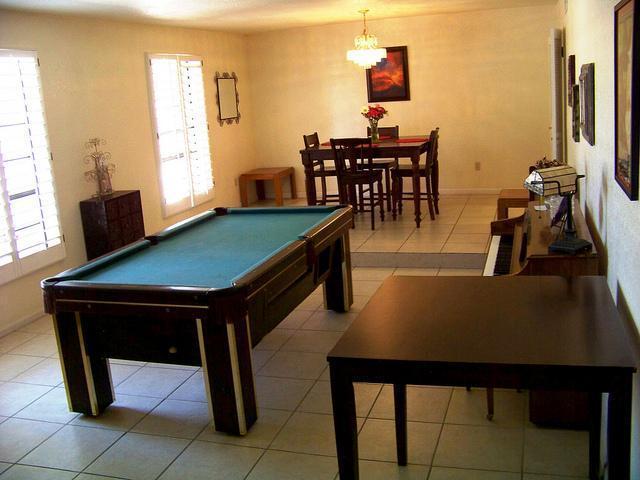How many lights are hanging from the ceiling?
Give a very brief answer. 1. How many people can sit at the same table?
Give a very brief answer. 4. How many lights are on?
Give a very brief answer. 1. 